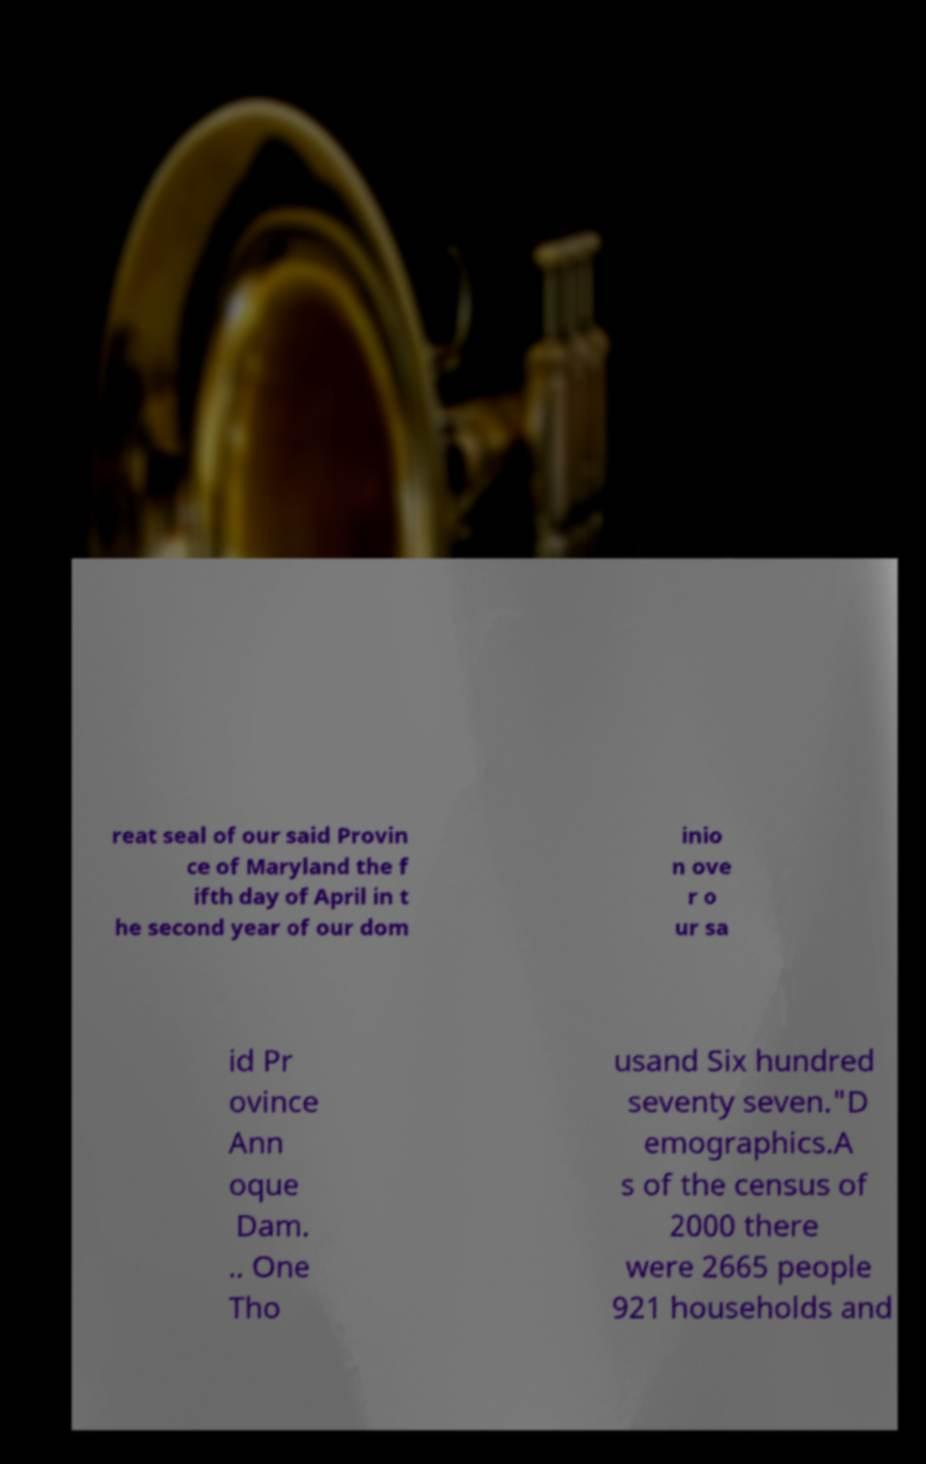What messages or text are displayed in this image? I need them in a readable, typed format. reat seal of our said Provin ce of Maryland the f ifth day of April in t he second year of our dom inio n ove r o ur sa id Pr ovince Ann oque Dam. .. One Tho usand Six hundred seventy seven."D emographics.A s of the census of 2000 there were 2665 people 921 households and 